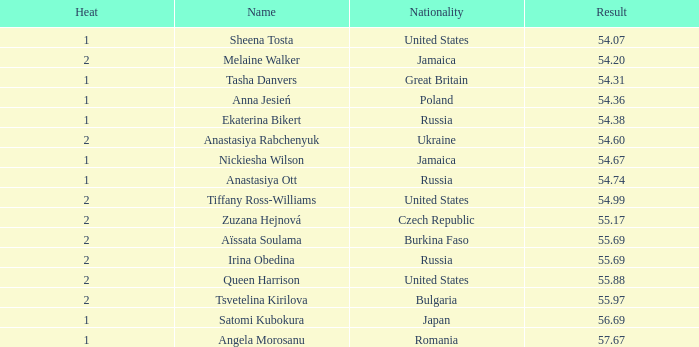Which Rank has a Name of tsvetelina kirilova, and a Result smaller than 55.97? None. Could you parse the entire table as a dict? {'header': ['Heat', 'Name', 'Nationality', 'Result'], 'rows': [['1', 'Sheena Tosta', 'United States', '54.07'], ['2', 'Melaine Walker', 'Jamaica', '54.20'], ['1', 'Tasha Danvers', 'Great Britain', '54.31'], ['1', 'Anna Jesień', 'Poland', '54.36'], ['1', 'Ekaterina Bikert', 'Russia', '54.38'], ['2', 'Anastasiya Rabchenyuk', 'Ukraine', '54.60'], ['1', 'Nickiesha Wilson', 'Jamaica', '54.67'], ['1', 'Anastasiya Ott', 'Russia', '54.74'], ['2', 'Tiffany Ross-Williams', 'United States', '54.99'], ['2', 'Zuzana Hejnová', 'Czech Republic', '55.17'], ['2', 'Aïssata Soulama', 'Burkina Faso', '55.69'], ['2', 'Irina Obedina', 'Russia', '55.69'], ['2', 'Queen Harrison', 'United States', '55.88'], ['2', 'Tsvetelina Kirilova', 'Bulgaria', '55.97'], ['1', 'Satomi Kubokura', 'Japan', '56.69'], ['1', 'Angela Morosanu', 'Romania', '57.67']]} 